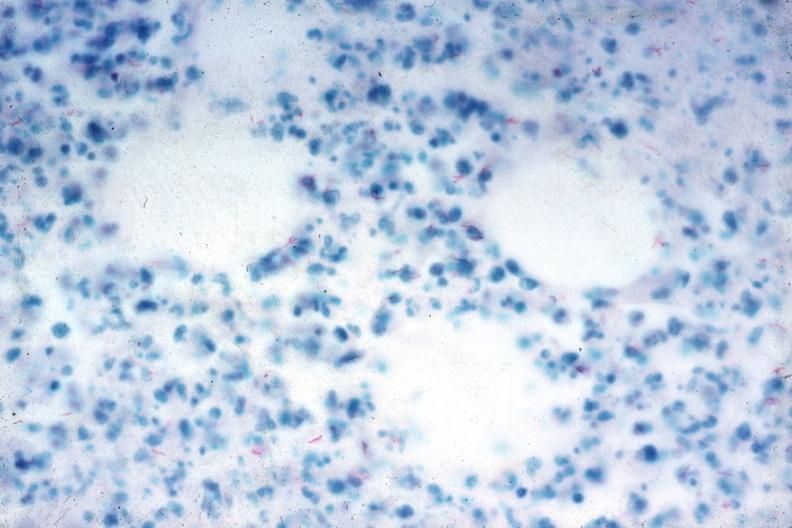s tuberculosis present?
Answer the question using a single word or phrase. Yes 